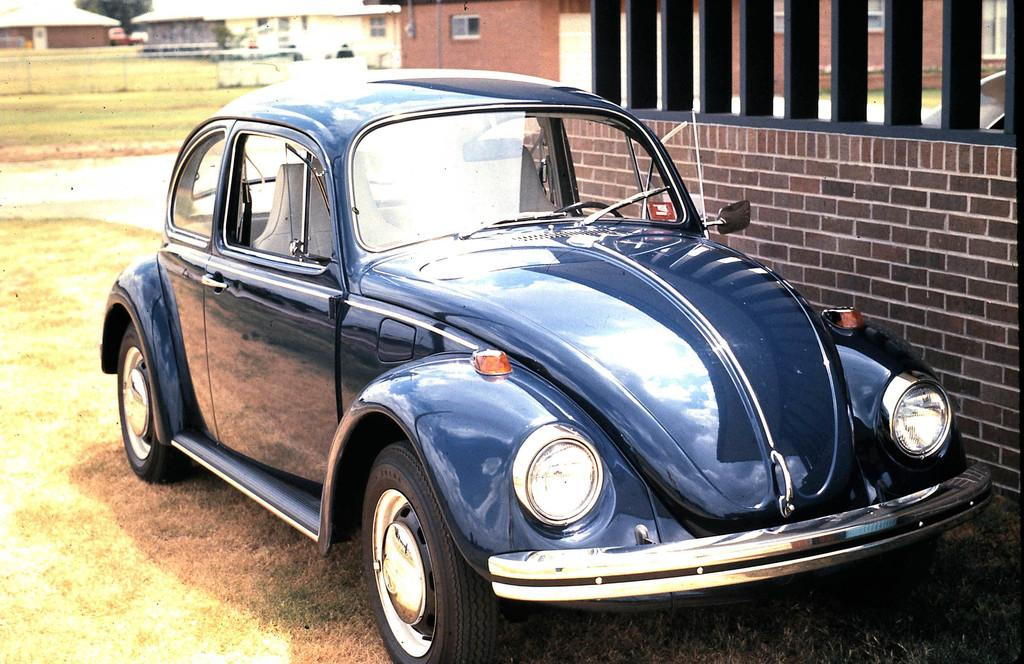What color is the car in the image? The car in the image is blue. Where is the car located in the image? The car is on the ground in the image. What type of vegetation is present on the ground? There is grass on the ground in the image. What can be seen on the right side of the image? There is a wall on the right side of the image. What type of structure is visible in the image? There is a building in the image. What type of quartz can be seen in the image? There is no quartz present in the image. How does the wren contribute to the thrill in the image? There is no wren or any indication of thrill in the image. 